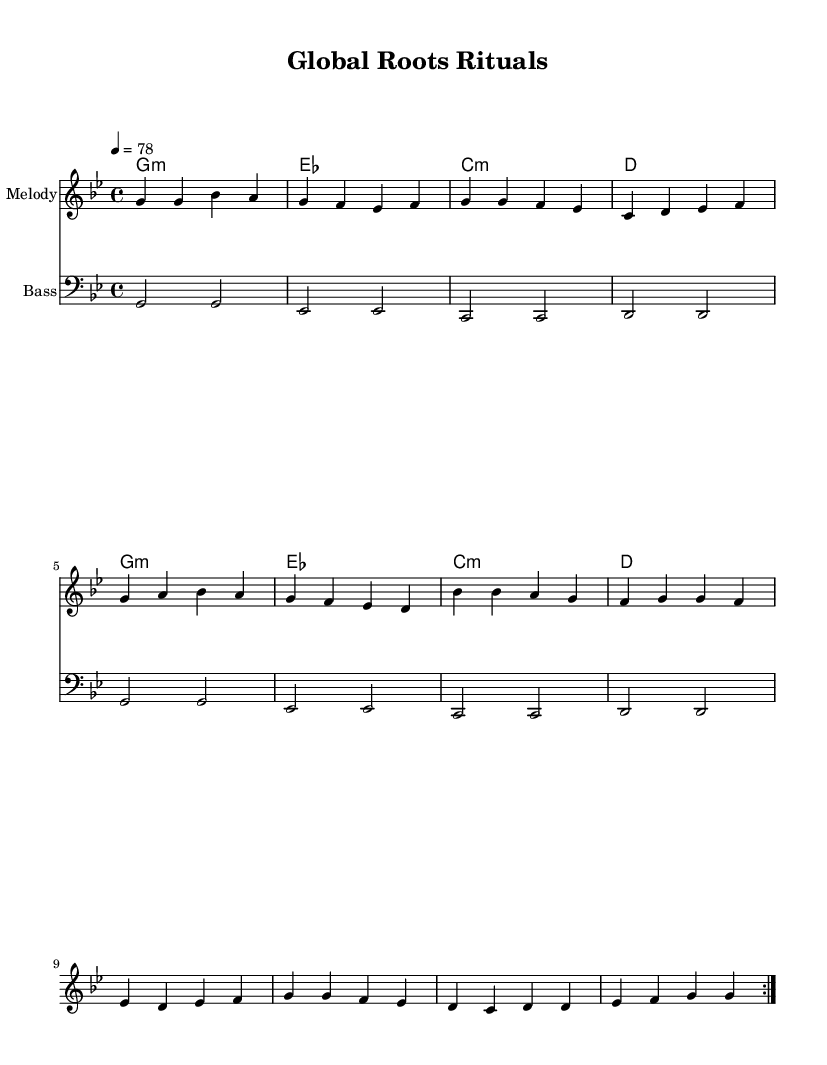What is the key signature of this music? The key signature is indicated at the beginning of the staff. Here, we see B flat and E flat. The presence of these two flats suggests that the key is G minor, which contains a B flat as the 6th degree and an E flat as part of the minor scale.
Answer: G minor What is the time signature of the piece? The time signature is found at the start of the score. In this case, it is displayed as a fraction, where the upper number (4) indicates the number of beats in each measure, and the lower number (4) denotes that the quarter note receives one beat. This means there are four beats per measure.
Answer: 4/4 What is the tempo marking of the music? The tempo marking is stated in the score above the melody. It specifies how fast the piece should be played. Here, it states "4 = 78," meaning there should be 78 beats per minute, with each beat corresponding to a quarter note.
Answer: 78 How many verses are in the song? The lyrics section shows a repeating structure in the verse. The repeat indication “\repeat volta 2” suggests that the verse is played two times. Since the lyrics provided correspond to this section divided into lines, we identify it as a single verse repeated twice.
Answer: 1 Name a cultural reference mentioned in the lyrics. In the lyrics, there are references to places like the "mountains of Tibet" and the "plains of Mali." These geographical locations are significant in their respective cultures and highlight the song's aspect of global customs. The mention of these geographical areas connects the music to traditional customs and rituals.
Answer: Tibet, Mali What unique rhythmic element is found in Reggae music shown here? Reggae music traditionally emphasizes the offbeats, often referred to as the "one drop" rhythm. In the score, while the melody and bass lines provide a foundation, the emphasis on syncopation can be seen in the placement of the notes. This style is characteristic of reggae and creates a laid-back feel.
Answer: Offbeat emphasis 